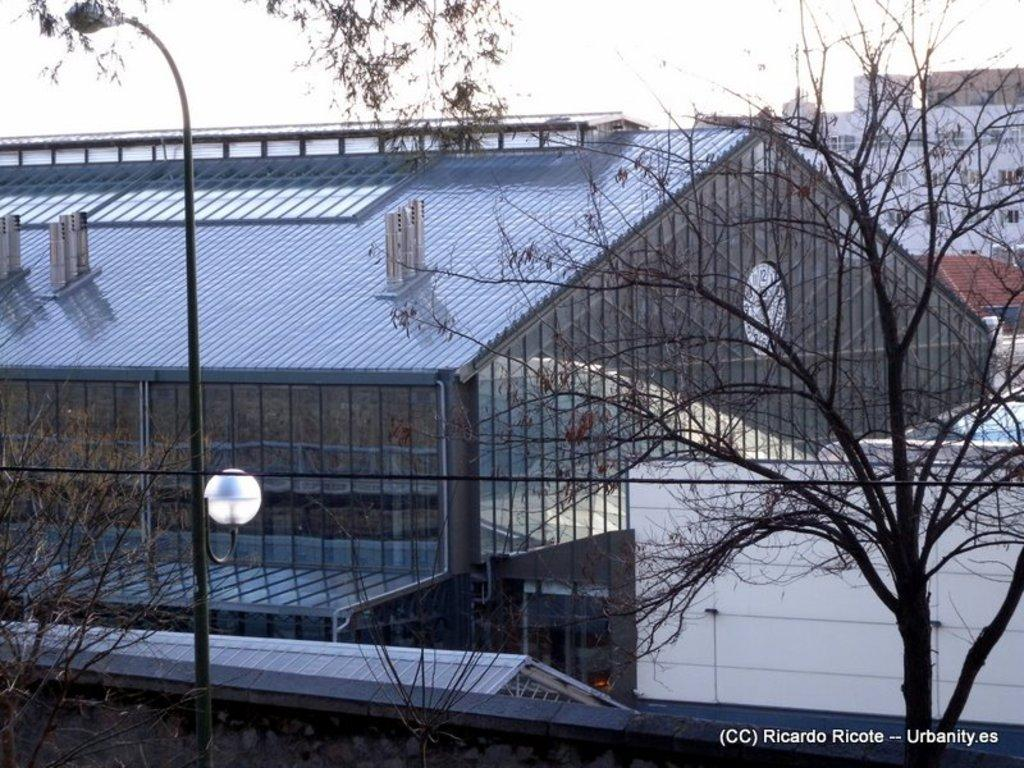What can be seen in the background of the image? There is a building in the background of the image. What is located on the ground in the image? There is a pole on the ground in the image. What type of vegetation is on the right side of the image? There is a tree on the right side of the image. How many buildings can be seen in the background of the image? There are buildings visible in the background of the image. What type of button can be seen on the tree in the image? There is no button present on the tree in the image. Is there a store visible in the image? The provided facts do not mention a store, so it cannot be determined if one is present in the image. 